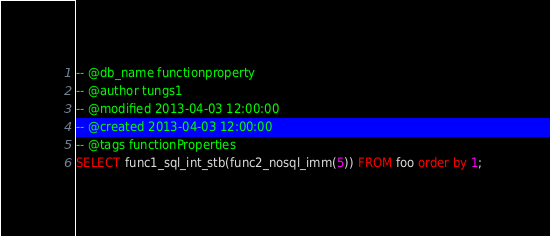Convert code to text. <code><loc_0><loc_0><loc_500><loc_500><_SQL_>-- @db_name functionproperty
-- @author tungs1
-- @modified 2013-04-03 12:00:00
-- @created 2013-04-03 12:00:00
-- @tags functionProperties 
SELECT func1_sql_int_stb(func2_nosql_imm(5)) FROM foo order by 1; 
</code> 